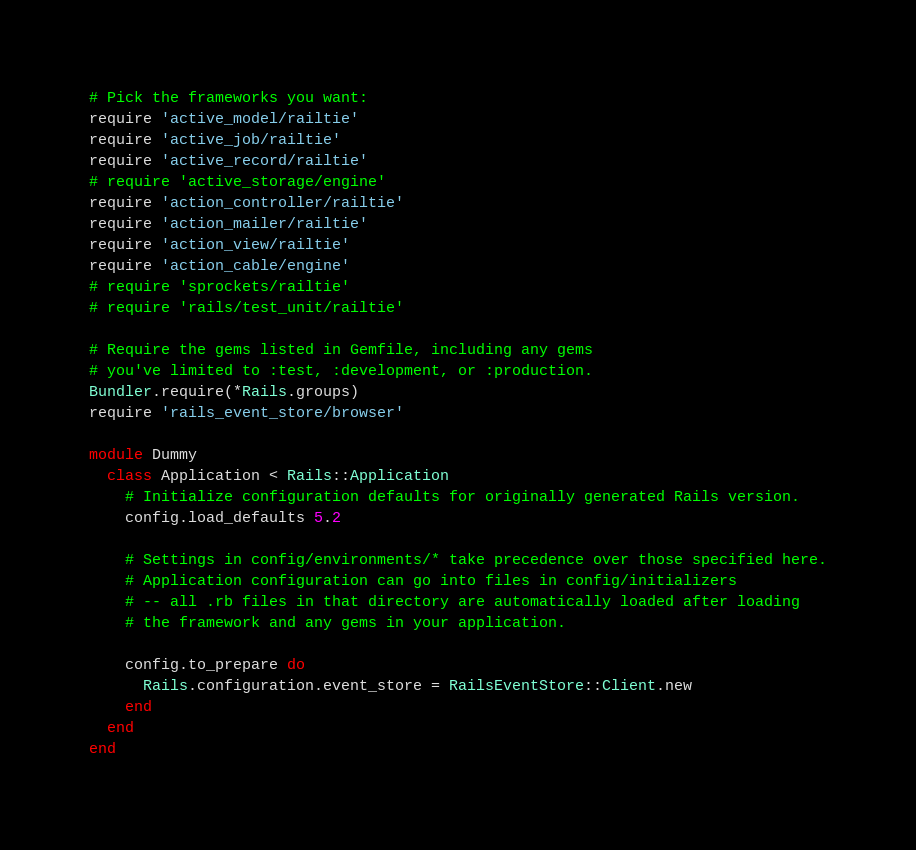Convert code to text. <code><loc_0><loc_0><loc_500><loc_500><_Ruby_># Pick the frameworks you want:
require 'active_model/railtie'
require 'active_job/railtie'
require 'active_record/railtie'
# require 'active_storage/engine'
require 'action_controller/railtie'
require 'action_mailer/railtie'
require 'action_view/railtie'
require 'action_cable/engine'
# require 'sprockets/railtie'
# require 'rails/test_unit/railtie'

# Require the gems listed in Gemfile, including any gems
# you've limited to :test, :development, or :production.
Bundler.require(*Rails.groups)
require 'rails_event_store/browser'

module Dummy
  class Application < Rails::Application
    # Initialize configuration defaults for originally generated Rails version.
    config.load_defaults 5.2

    # Settings in config/environments/* take precedence over those specified here.
    # Application configuration can go into files in config/initializers
    # -- all .rb files in that directory are automatically loaded after loading
    # the framework and any gems in your application.

    config.to_prepare do
      Rails.configuration.event_store = RailsEventStore::Client.new
    end
  end
end
</code> 